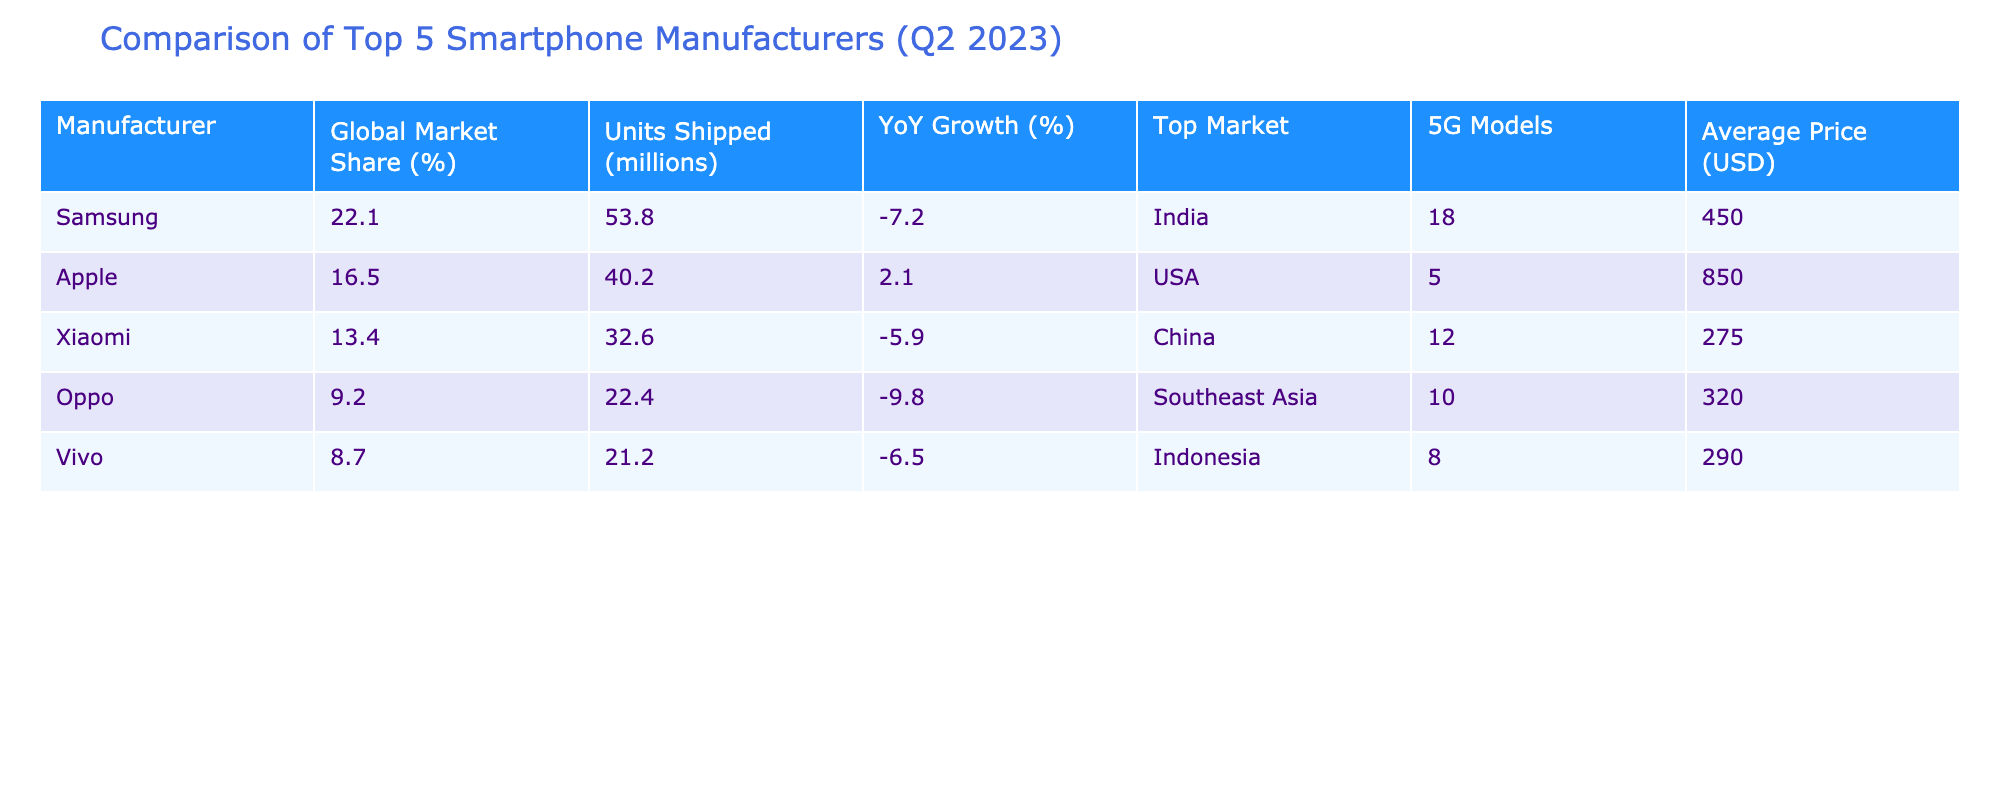What is the global market share percentage of Xiaomi? From the table, the global market share percentage for Xiaomi is explicitly mentioned under the "Global Market Share (%)" column. The value listed is 13.4%.
Answer: 13.4% Which manufacturer shipped the most units in Q2 2023? By comparing the "Units Shipped (millions)" column for each manufacturer, Samsung has the highest value at 53.8 million units.
Answer: Samsung Is Apple's YoY growth positive or negative? The "YoY Growth (%)" for Apple is listed as 2.1%, which is a positive growth rate. Therefore, it indicates that Apple experienced growth over the previous year.
Answer: Yes What is the average price of Oppo's smartphones? The average price for Oppo smartphones is provided directly in the table under the "Average Price (USD)" column, which is listed as 320 USD.
Answer: 320 USD Which two manufacturers have a higher global market share than Vivo? By examining the "Global Market Share (%)" column, both Samsung (22.1%) and Apple (16.5%) have higher percentages than Vivo (8.7%). Therefore, the two manufacturers that meet the criteria are Samsung and Apple.
Answer: Samsung, Apple What is the total market share percentage of the top three manufacturers? To find the total market share of the top three manufacturers (Samsung, Apple, Xiaomi), we sum their market shares: 22.1% (Samsung) + 16.5% (Apple) + 13.4% (Xiaomi) = 52%. Therefore, the total market share percentage is 52%.
Answer: 52% Did any manufacturer experience a YoY growth of over 5%? When evaluating the "YoY Growth (%)" for all manufacturers, we see that none of them have a growth percentage exceeding 5%, as the highest is 2.1% for Apple. Thus, the statement is false.
Answer: No Which manufacturer has the lowest average price among the top five? By comparing the "Average Price (USD)" column, we find that Xiaomi has the lowest average price at 275 USD among the five manufacturers listed.
Answer: Xiaomi What is the difference in units shipped between Samsung and Vivo? To calculate the difference, we subtract the units shipped by Vivo from those shipped by Samsung: 53.8 million (Samsung) - 21.2 million (Vivo) = 32.6 million. Thus, the difference is 32.6 million units.
Answer: 32.6 million units 